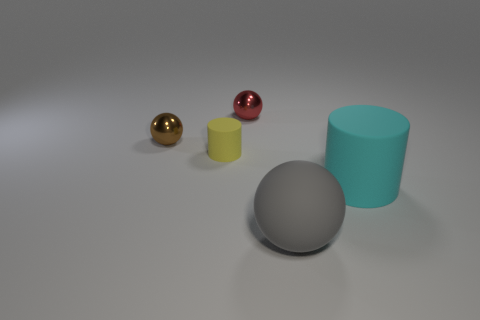Is the material of the gray thing the same as the tiny sphere to the right of the tiny yellow matte cylinder?
Your answer should be very brief. No. Is there a matte cylinder that is left of the rubber cylinder left of the metallic object that is behind the brown metallic ball?
Your response must be concise. No. Are there any other things that are the same size as the red ball?
Offer a terse response. Yes. What is the color of the large object that is made of the same material as the big cylinder?
Make the answer very short. Gray. What is the size of the thing that is left of the gray ball and in front of the brown shiny thing?
Your answer should be compact. Small. Are there fewer yellow rubber things that are in front of the big sphere than big cyan cylinders to the left of the red shiny sphere?
Provide a short and direct response. No. Do the cylinder on the left side of the large cyan rubber cylinder and the ball behind the brown thing have the same material?
Offer a terse response. No. There is a rubber thing that is behind the gray rubber thing and right of the tiny rubber cylinder; what is its shape?
Your answer should be very brief. Cylinder. What is the material of the tiny object right of the cylinder that is on the left side of the large ball?
Provide a succinct answer. Metal. Is the number of tiny matte cylinders greater than the number of rubber things?
Your response must be concise. No. 